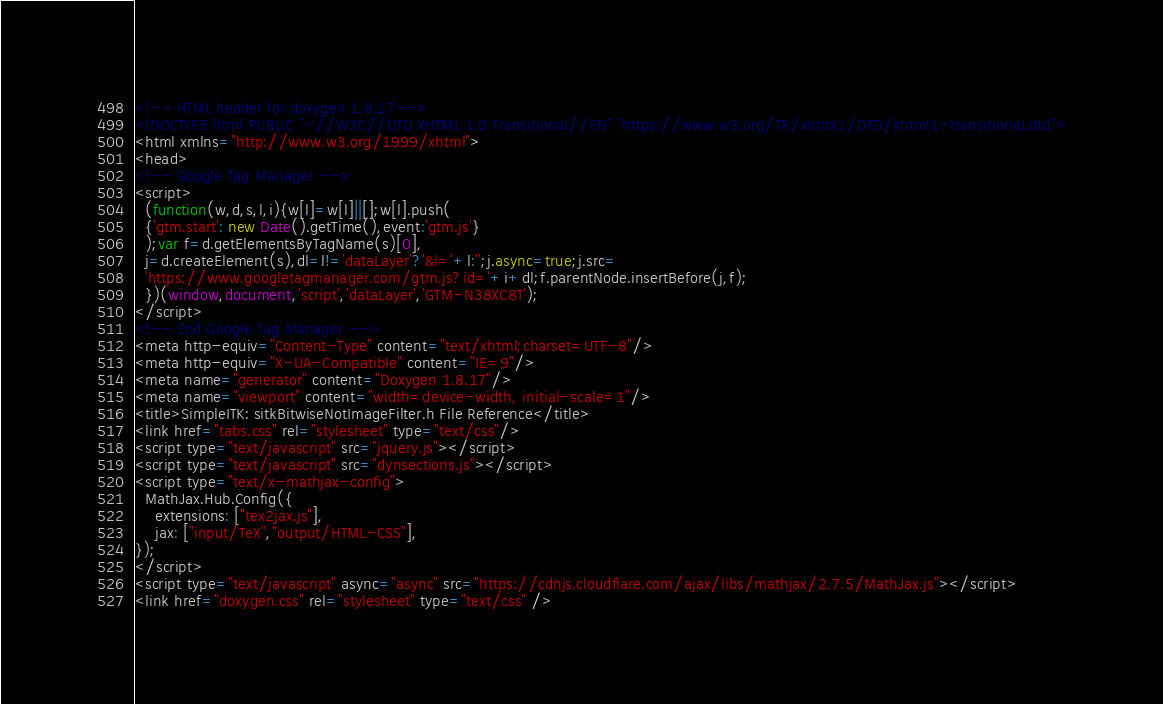Convert code to text. <code><loc_0><loc_0><loc_500><loc_500><_HTML_><!-- HTML header for doxygen 1.8.17-->
<!DOCTYPE html PUBLIC "-//W3C//DTD XHTML 1.0 Transitional//EN" "https://www.w3.org/TR/xhtml1/DTD/xhtml1-transitional.dtd">
<html xmlns="http://www.w3.org/1999/xhtml">
<head>
<!-- Google Tag Manager -->
<script>
  (function(w,d,s,l,i){w[l]=w[l]||[];w[l].push(
  {'gtm.start': new Date().getTime(),event:'gtm.js'}
  );var f=d.getElementsByTagName(s)[0],
  j=d.createElement(s),dl=l!='dataLayer'?'&l='+l:'';j.async=true;j.src=
  'https://www.googletagmanager.com/gtm.js?id='+i+dl;f.parentNode.insertBefore(j,f);
  })(window,document,'script','dataLayer','GTM-N38XC8T');
</script>
<!-- End Google Tag Manager -->
<meta http-equiv="Content-Type" content="text/xhtml;charset=UTF-8"/>
<meta http-equiv="X-UA-Compatible" content="IE=9"/>
<meta name="generator" content="Doxygen 1.8.17"/>
<meta name="viewport" content="width=device-width, initial-scale=1"/>
<title>SimpleITK: sitkBitwiseNotImageFilter.h File Reference</title>
<link href="tabs.css" rel="stylesheet" type="text/css"/>
<script type="text/javascript" src="jquery.js"></script>
<script type="text/javascript" src="dynsections.js"></script>
<script type="text/x-mathjax-config">
  MathJax.Hub.Config({
    extensions: ["tex2jax.js"],
    jax: ["input/TeX","output/HTML-CSS"],
});
</script>
<script type="text/javascript" async="async" src="https://cdnjs.cloudflare.com/ajax/libs/mathjax/2.7.5/MathJax.js"></script>
<link href="doxygen.css" rel="stylesheet" type="text/css" /></code> 